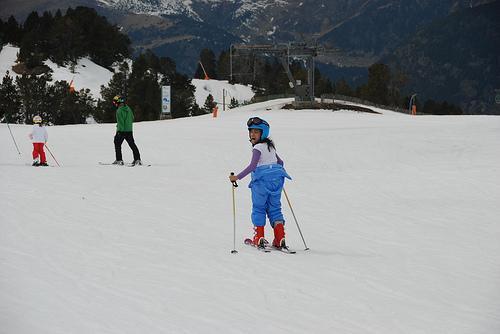How many people wearing green tops are in the image?
Give a very brief answer. 1. How many people are on purple snow?
Give a very brief answer. 0. 